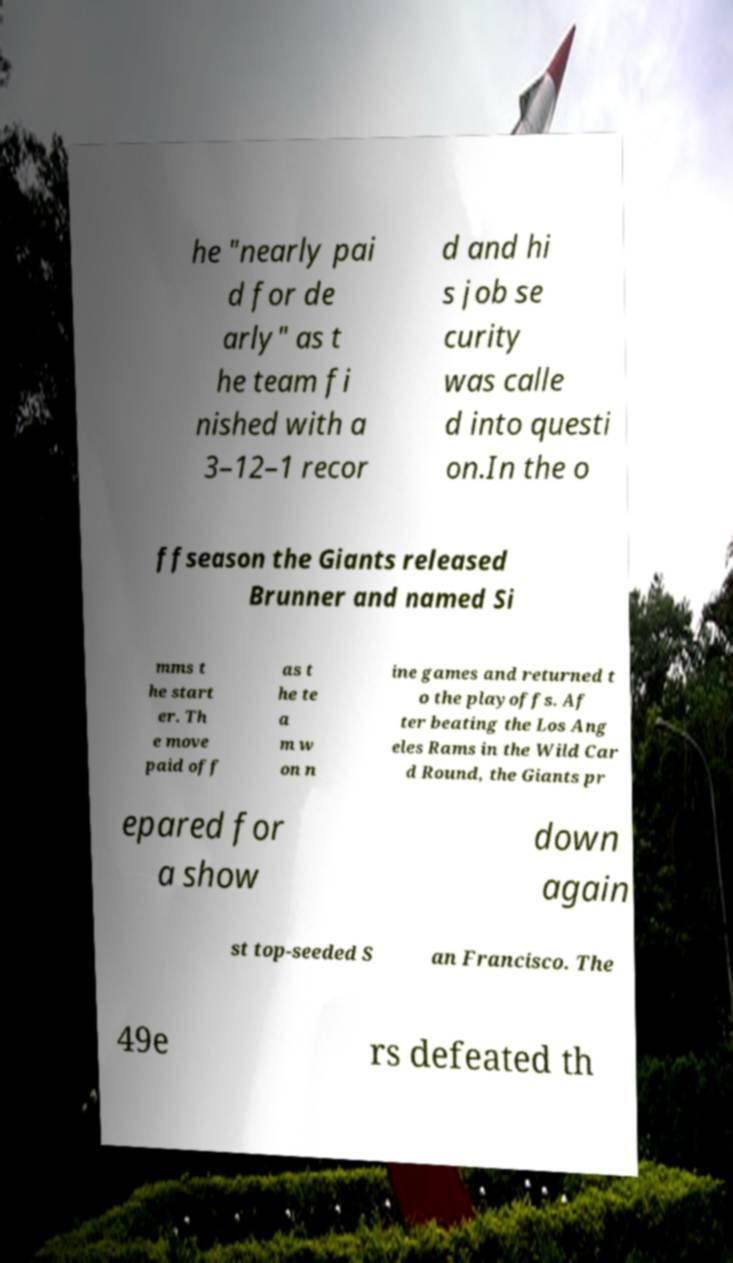What messages or text are displayed in this image? I need them in a readable, typed format. he "nearly pai d for de arly" as t he team fi nished with a 3–12–1 recor d and hi s job se curity was calle d into questi on.In the o ffseason the Giants released Brunner and named Si mms t he start er. Th e move paid off as t he te a m w on n ine games and returned t o the playoffs. Af ter beating the Los Ang eles Rams in the Wild Car d Round, the Giants pr epared for a show down again st top-seeded S an Francisco. The 49e rs defeated th 